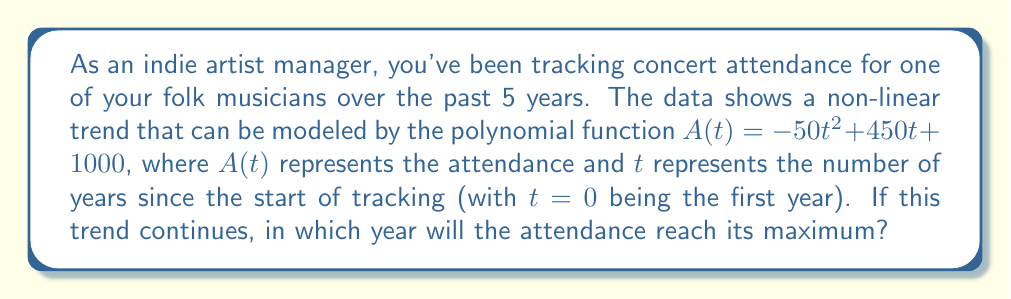Can you answer this question? To find the year when attendance reaches its maximum, we need to follow these steps:

1) The function $A(t) = -50t^2 + 450t + 1000$ is a quadratic function, which forms a parabola when graphed. The maximum point of a parabola occurs at its vertex.

2) For a quadratic function in the form $f(t) = at^2 + bt + c$, the t-coordinate of the vertex is given by $t = -\frac{b}{2a}$.

3) In our function, $a = -50$ and $b = 450$. Let's substitute these values:

   $t = -\frac{450}{2(-50)} = -\frac{450}{-100} = \frac{450}{100} = 4.5$

4) This means the maximum attendance occurs 4.5 years after the start of tracking.

5) Since we started tracking at year 0, and we're dealing with whole years, we need to round 4.5 to the nearest whole number.

6) Rounding 4.5 gives us 5.

7) Therefore, the attendance will reach its maximum in the 5th year of tracking.
Answer: 5th year 